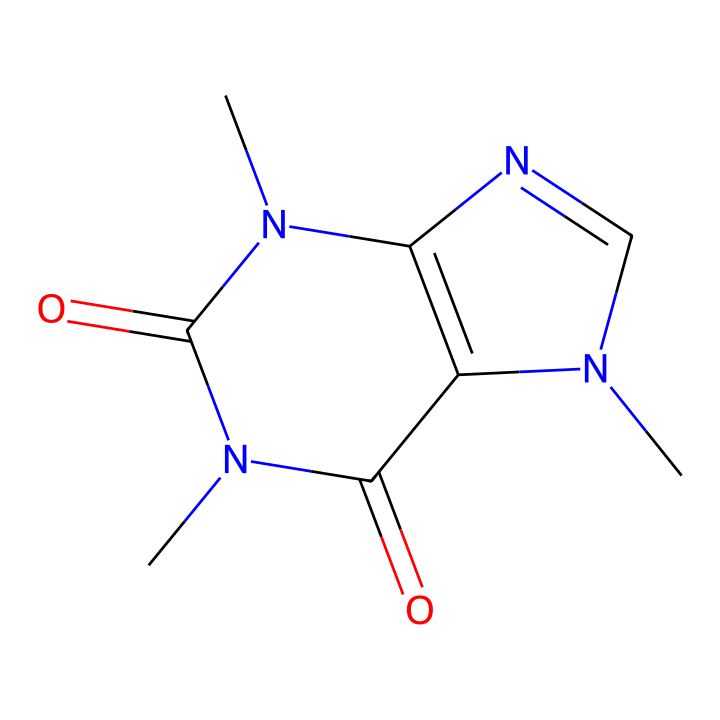What is the name of this chemical structure? The SMILES representation corresponds to caffeine, which is a well-known alkaloid found in coffee and tea.
Answer: caffeine How many nitrogen atoms are present in this structure? By analyzing the SMILES, we see there are three nitrogen atoms (N) in the chemical structure.
Answer: three What type of chemical compound is caffeine classified as? Caffeine is primarily classified as an alkaloid due to its nitrogen-containing structure and pharmacological effects.
Answer: alkaloid How many rings are present in the chemical structure of caffeine? This SMILES indicates that there are two fused rings in the chemical structure, which is characteristic of many alkaloids.
Answer: two Is caffeine a stimulant or depressant? Caffeine is classified as a stimulant, which is supported by its structure that interacts with the central nervous system.
Answer: stimulant What is the molecular formula of caffeine? From the structure, we deduce that the molecular formula of caffeine is C8H10N4O2, which includes all the given atoms in the SMILES.
Answer: C8H10N4O2 